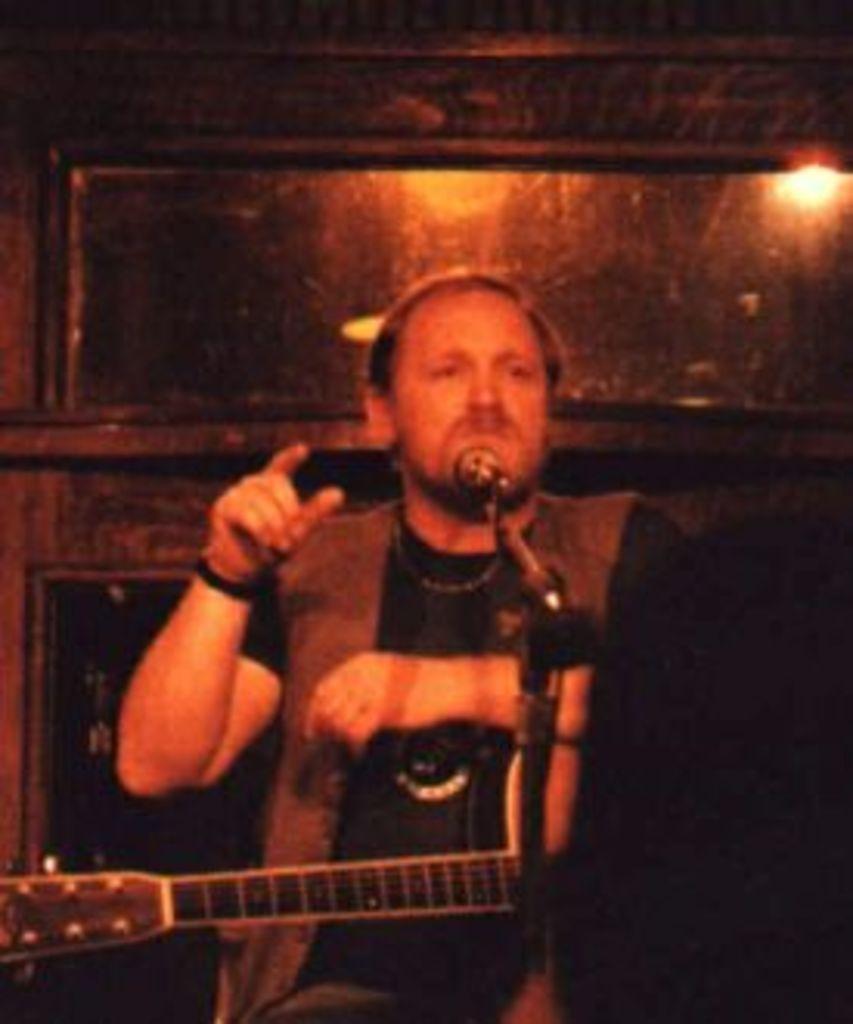In one or two sentences, can you explain what this image depicts? In the center of the image we can see a man standing and holding a guitar, before him there is a mic placed on the stand. In the background there is a wall and we can see a light. 